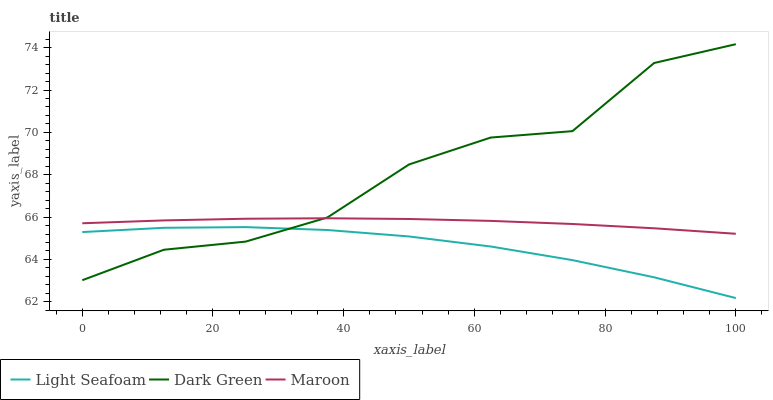Does Light Seafoam have the minimum area under the curve?
Answer yes or no. Yes. Does Dark Green have the maximum area under the curve?
Answer yes or no. Yes. Does Maroon have the minimum area under the curve?
Answer yes or no. No. Does Maroon have the maximum area under the curve?
Answer yes or no. No. Is Maroon the smoothest?
Answer yes or no. Yes. Is Dark Green the roughest?
Answer yes or no. Yes. Is Dark Green the smoothest?
Answer yes or no. No. Is Maroon the roughest?
Answer yes or no. No. Does Light Seafoam have the lowest value?
Answer yes or no. Yes. Does Dark Green have the lowest value?
Answer yes or no. No. Does Dark Green have the highest value?
Answer yes or no. Yes. Does Maroon have the highest value?
Answer yes or no. No. Is Light Seafoam less than Maroon?
Answer yes or no. Yes. Is Maroon greater than Light Seafoam?
Answer yes or no. Yes. Does Dark Green intersect Light Seafoam?
Answer yes or no. Yes. Is Dark Green less than Light Seafoam?
Answer yes or no. No. Is Dark Green greater than Light Seafoam?
Answer yes or no. No. Does Light Seafoam intersect Maroon?
Answer yes or no. No. 